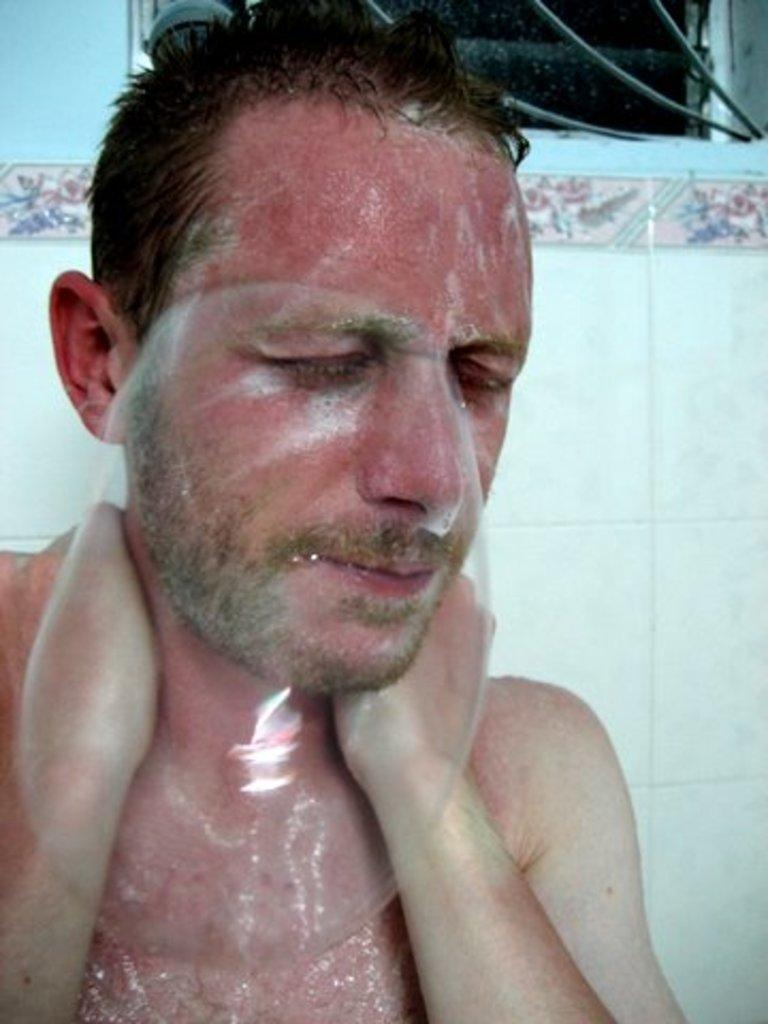Who is present in the image? There is a man in the image. What can be seen in the background of the image? There is a wall in the background of the image. What color is the copper back of the man in the image? There is no mention of copper or a back in the image, so it cannot be determined from the image. 